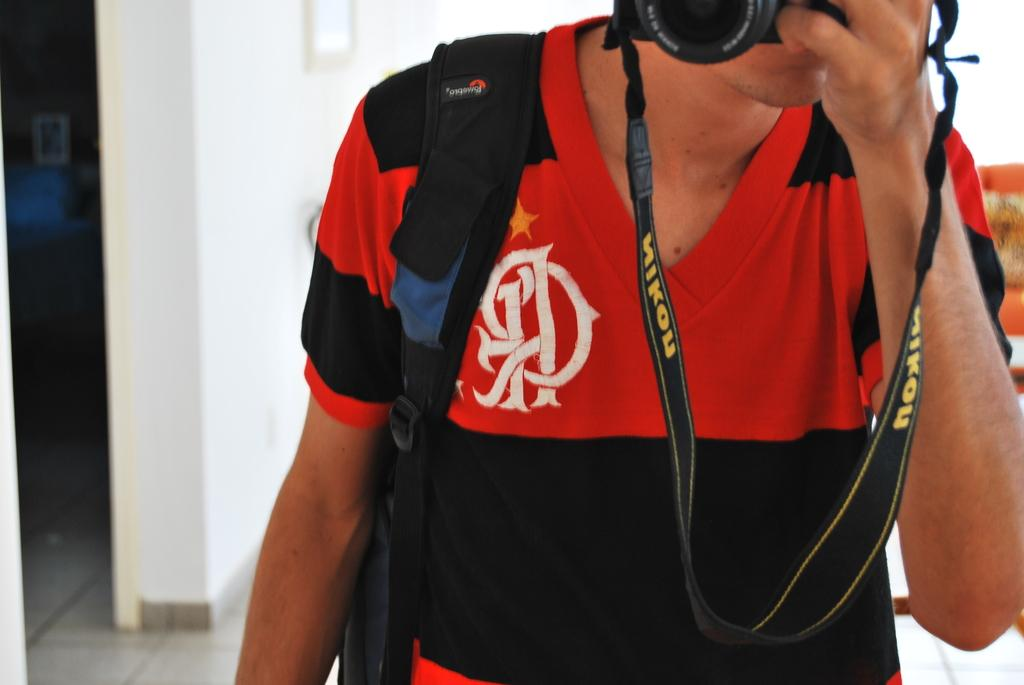<image>
Write a terse but informative summary of the picture. A man holds a camera attached to a black Nikon camera strap. 